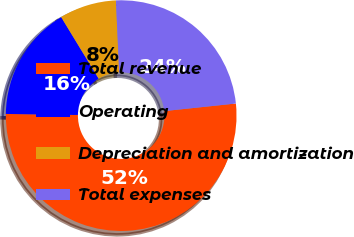<chart> <loc_0><loc_0><loc_500><loc_500><pie_chart><fcel>Total revenue<fcel>Operating<fcel>Depreciation and amortization<fcel>Total expenses<nl><fcel>51.9%<fcel>16.06%<fcel>7.98%<fcel>24.05%<nl></chart> 